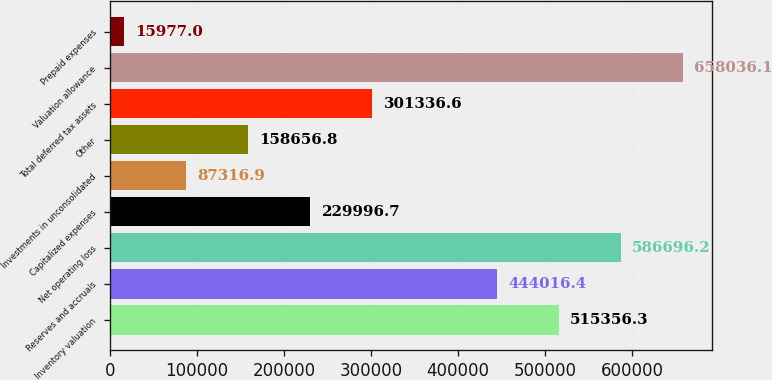Convert chart to OTSL. <chart><loc_0><loc_0><loc_500><loc_500><bar_chart><fcel>Inventory valuation<fcel>Reserves and accruals<fcel>Net operating loss<fcel>Capitalized expenses<fcel>Investments in unconsolidated<fcel>Other<fcel>Total deferred tax assets<fcel>Valuation allowance<fcel>Prepaid expenses<nl><fcel>515356<fcel>444016<fcel>586696<fcel>229997<fcel>87316.9<fcel>158657<fcel>301337<fcel>658036<fcel>15977<nl></chart> 